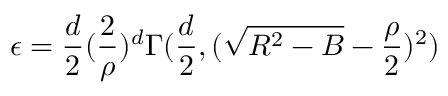Convert formula to latex. <formula><loc_0><loc_0><loc_500><loc_500>\epsilon = \frac { d } { 2 } ( \frac { 2 } { \rho } ) ^ { d } \Gamma ( \frac { d } { 2 } , ( \sqrt { R ^ { 2 } - B } - \frac { \rho } { 2 } ) ^ { 2 } )</formula> 